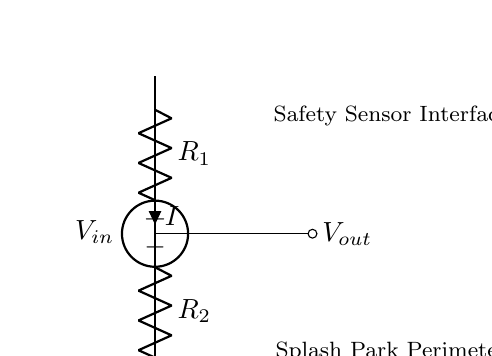What is the voltage source in this circuit? The voltage source is labeled as V_in in the circuit diagram, indicating the input voltage supplied to the circuit.
Answer: V_in What are the two resistors in the voltage divider? The resistors in the voltage divider are identified as R_1 and R_2 in the circuit diagram, representing the two components that divide the input voltage.
Answer: R_1 and R_2 What is the output voltage labeled as in the diagram? The output voltage is labeled as V_out, which is taken from the junction between the two resistors in the voltage divider circuit.
Answer: V_out How many connections are there in the circuit? The circuit contains four main connections: the voltage source, the two resistors, and the output node where V_out is taken. Counting these gives us four connections.
Answer: Four What happens to the output voltage if R_1 increases? If R_1 increases while R_2 remains the same, the output voltage V_out will increase according to the voltage divider formula, which shows that a larger R_1 results in a higher proportion of V_in appearing across R_1.
Answer: V_out increases Which component interfaces with the safety sensors? The output voltage V_out interfaces with the safety sensors, as indicated in the circuit diagram. This output is used for monitoring or triggering safety measures around the splash park perimeter.
Answer: V_out 